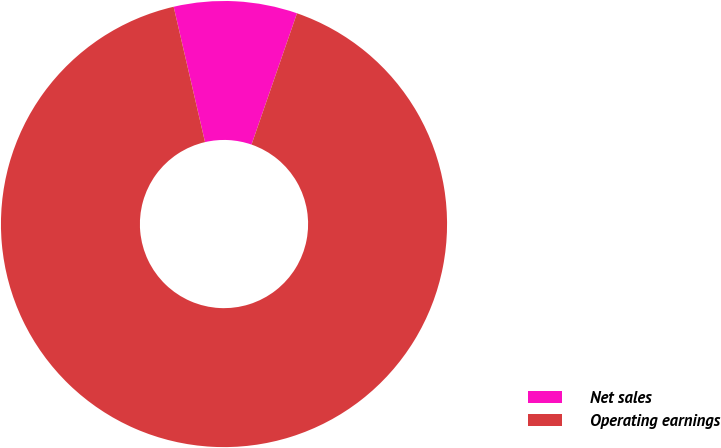Convert chart. <chart><loc_0><loc_0><loc_500><loc_500><pie_chart><fcel>Net sales<fcel>Operating earnings<nl><fcel>8.93%<fcel>91.07%<nl></chart> 